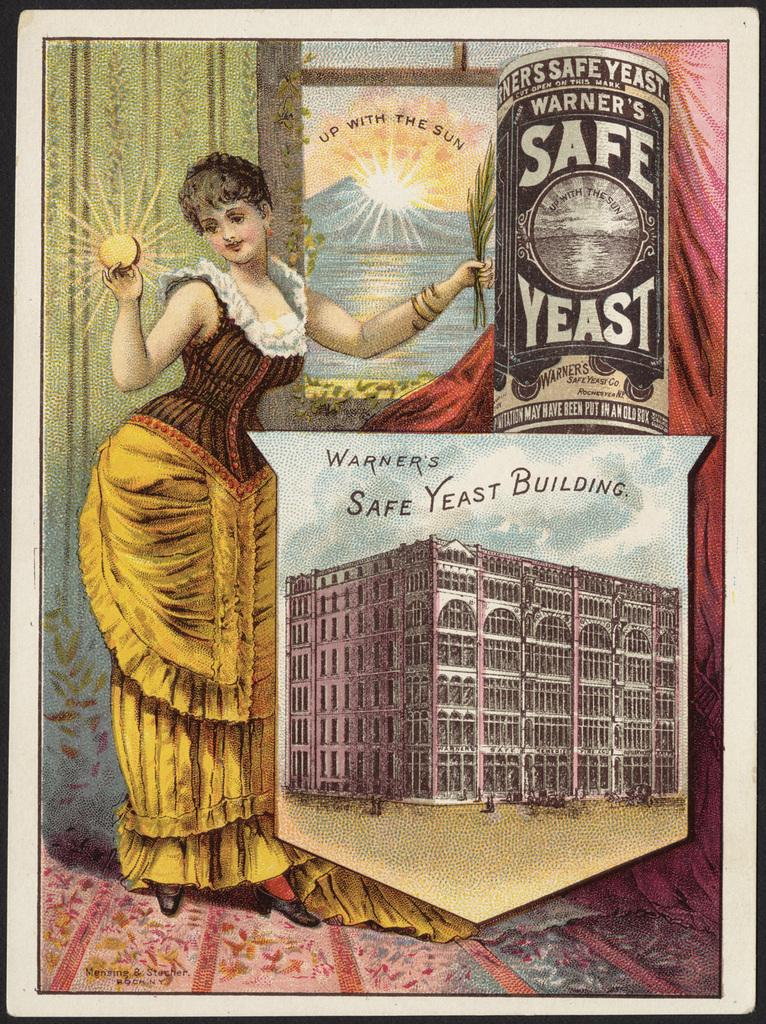<image>
Share a concise interpretation of the image provided. An ad for Warners Safe Yeast features a woman in in yellow in front of a window 